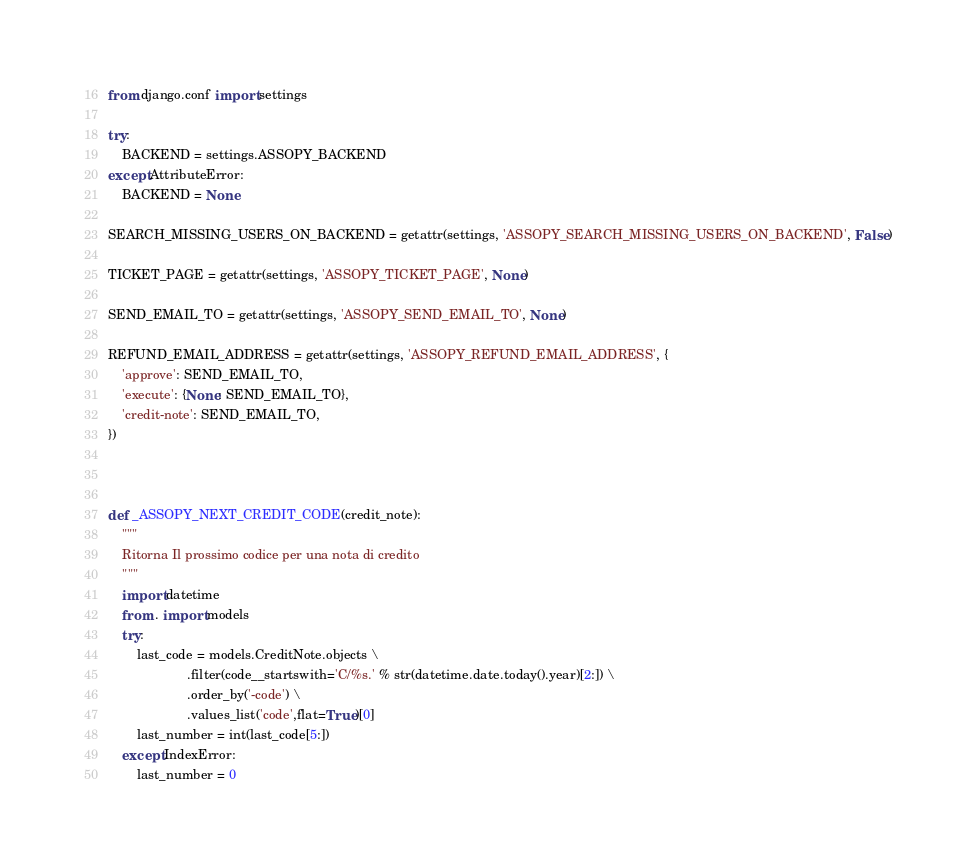Convert code to text. <code><loc_0><loc_0><loc_500><loc_500><_Python_>
from django.conf import settings

try:
    BACKEND = settings.ASSOPY_BACKEND
except AttributeError:
    BACKEND = None

SEARCH_MISSING_USERS_ON_BACKEND = getattr(settings, 'ASSOPY_SEARCH_MISSING_USERS_ON_BACKEND', False)

TICKET_PAGE = getattr(settings, 'ASSOPY_TICKET_PAGE', None)

SEND_EMAIL_TO = getattr(settings, 'ASSOPY_SEND_EMAIL_TO', None)

REFUND_EMAIL_ADDRESS = getattr(settings, 'ASSOPY_REFUND_EMAIL_ADDRESS', {
    'approve': SEND_EMAIL_TO,
    'execute': {None: SEND_EMAIL_TO},
    'credit-note': SEND_EMAIL_TO,
})



def _ASSOPY_NEXT_CREDIT_CODE(credit_note):
    """
    Ritorna Il prossimo codice per una nota di credito
    """
    import datetime
    from . import models
    try:
        last_code = models.CreditNote.objects \
                      .filter(code__startswith='C/%s.' % str(datetime.date.today().year)[2:]) \
                      .order_by('-code') \
                      .values_list('code',flat=True)[0]
        last_number = int(last_code[5:])
    except IndexError:
        last_number = 0
</code> 